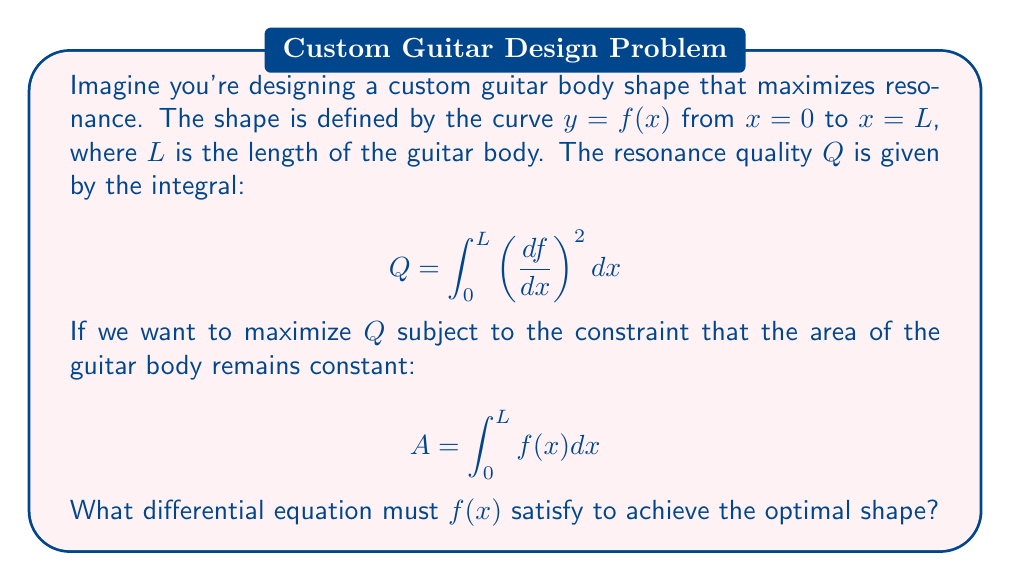Show me your answer to this math problem. To solve this problem, we'll use the calculus of variations and the Euler-Lagrange equation. Here are the steps:

1) We need to maximize $Q$ subject to the constraint on $A$. We can use the method of Lagrange multipliers. Let's form the functional:

   $$ J[f] = \int_0^L \left[\left(\frac{df}{dx}\right)^2 + \lambda f(x)\right] dx $$

   where $\lambda$ is the Lagrange multiplier.

2) The Euler-Lagrange equation for this functional is:

   $$ \frac{\partial F}{\partial f} - \frac{d}{dx}\left(\frac{\partial F}{\partial f'}\right) = 0 $$

   where $F = (f')^2 + \lambda f$ and $f' = \frac{df}{dx}$.

3) Calculating the partial derivatives:

   $\frac{\partial F}{\partial f} = \lambda$
   $\frac{\partial F}{\partial f'} = 2f'$

4) Substituting into the Euler-Lagrange equation:

   $$ \lambda - \frac{d}{dx}(2f') = 0 $$

5) Simplifying:

   $$ \lambda - 2f'' = 0 $$
   $$ f'' = \frac{\lambda}{2} $$

This is the differential equation that $f(x)$ must satisfy for the optimal guitar body shape.
Answer: $f''(x) = \frac{\lambda}{2}$ 